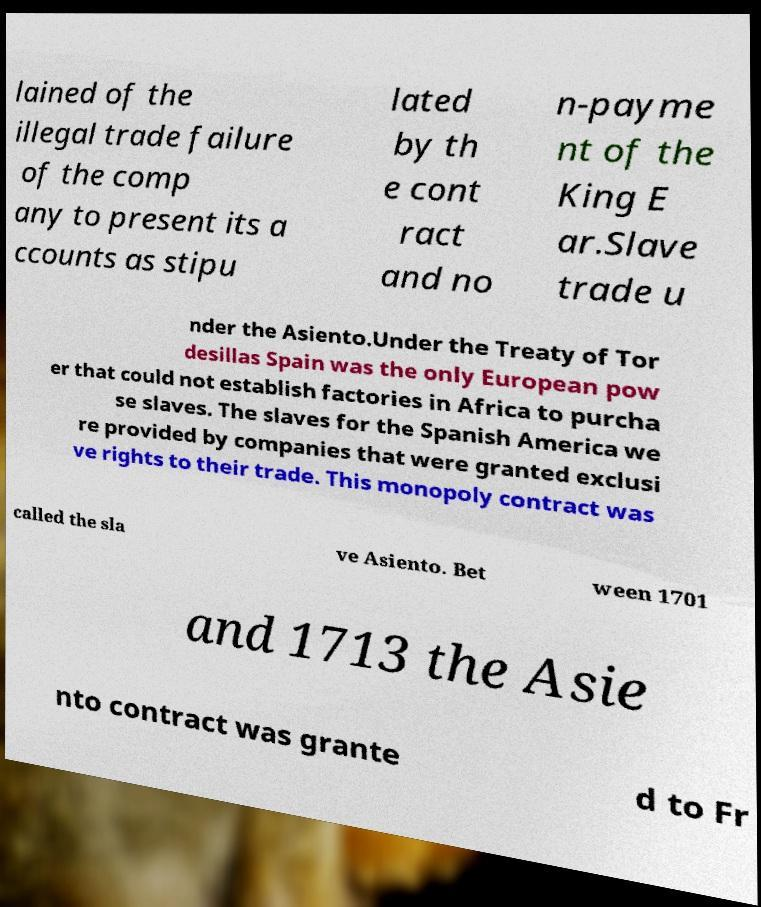Can you accurately transcribe the text from the provided image for me? lained of the illegal trade failure of the comp any to present its a ccounts as stipu lated by th e cont ract and no n-payme nt of the King E ar.Slave trade u nder the Asiento.Under the Treaty of Tor desillas Spain was the only European pow er that could not establish factories in Africa to purcha se slaves. The slaves for the Spanish America we re provided by companies that were granted exclusi ve rights to their trade. This monopoly contract was called the sla ve Asiento. Bet ween 1701 and 1713 the Asie nto contract was grante d to Fr 